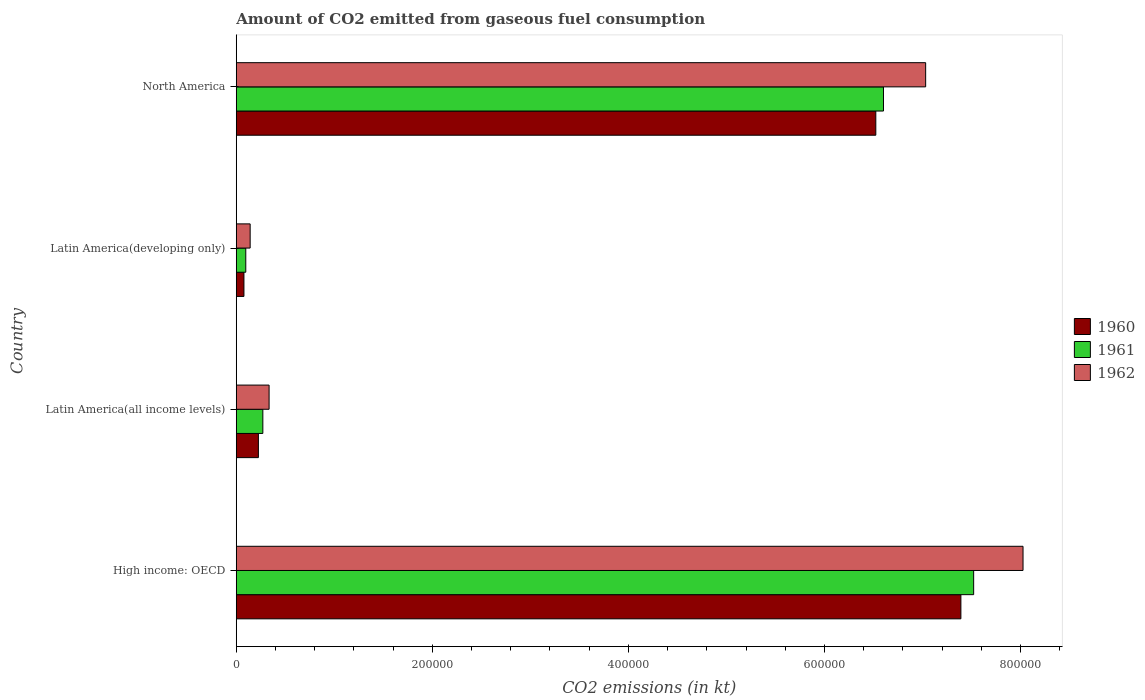How many different coloured bars are there?
Your answer should be compact. 3. How many groups of bars are there?
Your answer should be very brief. 4. Are the number of bars on each tick of the Y-axis equal?
Your answer should be compact. Yes. How many bars are there on the 4th tick from the bottom?
Make the answer very short. 3. What is the label of the 4th group of bars from the top?
Make the answer very short. High income: OECD. What is the amount of CO2 emitted in 1962 in North America?
Make the answer very short. 7.03e+05. Across all countries, what is the maximum amount of CO2 emitted in 1962?
Your answer should be compact. 8.03e+05. Across all countries, what is the minimum amount of CO2 emitted in 1962?
Give a very brief answer. 1.42e+04. In which country was the amount of CO2 emitted in 1962 maximum?
Provide a succinct answer. High income: OECD. In which country was the amount of CO2 emitted in 1962 minimum?
Give a very brief answer. Latin America(developing only). What is the total amount of CO2 emitted in 1962 in the graph?
Your response must be concise. 1.55e+06. What is the difference between the amount of CO2 emitted in 1961 in High income: OECD and that in Latin America(all income levels)?
Ensure brevity in your answer.  7.25e+05. What is the difference between the amount of CO2 emitted in 1960 in North America and the amount of CO2 emitted in 1961 in Latin America(all income levels)?
Your response must be concise. 6.25e+05. What is the average amount of CO2 emitted in 1962 per country?
Your response must be concise. 3.88e+05. What is the difference between the amount of CO2 emitted in 1961 and amount of CO2 emitted in 1962 in North America?
Your response must be concise. -4.30e+04. In how many countries, is the amount of CO2 emitted in 1962 greater than 80000 kt?
Provide a succinct answer. 2. What is the ratio of the amount of CO2 emitted in 1960 in High income: OECD to that in Latin America(developing only)?
Your answer should be compact. 94.3. What is the difference between the highest and the second highest amount of CO2 emitted in 1962?
Make the answer very short. 9.93e+04. What is the difference between the highest and the lowest amount of CO2 emitted in 1962?
Your answer should be very brief. 7.88e+05. In how many countries, is the amount of CO2 emitted in 1961 greater than the average amount of CO2 emitted in 1961 taken over all countries?
Your response must be concise. 2. Is the sum of the amount of CO2 emitted in 1962 in Latin America(all income levels) and North America greater than the maximum amount of CO2 emitted in 1961 across all countries?
Provide a succinct answer. No. What does the 3rd bar from the bottom in North America represents?
Your response must be concise. 1962. Is it the case that in every country, the sum of the amount of CO2 emitted in 1960 and amount of CO2 emitted in 1962 is greater than the amount of CO2 emitted in 1961?
Provide a succinct answer. Yes. What is the difference between two consecutive major ticks on the X-axis?
Make the answer very short. 2.00e+05. How many legend labels are there?
Your answer should be very brief. 3. How are the legend labels stacked?
Provide a succinct answer. Vertical. What is the title of the graph?
Your answer should be very brief. Amount of CO2 emitted from gaseous fuel consumption. What is the label or title of the X-axis?
Provide a short and direct response. CO2 emissions (in kt). What is the CO2 emissions (in kt) in 1960 in High income: OECD?
Make the answer very short. 7.39e+05. What is the CO2 emissions (in kt) of 1961 in High income: OECD?
Provide a short and direct response. 7.52e+05. What is the CO2 emissions (in kt) of 1962 in High income: OECD?
Provide a short and direct response. 8.03e+05. What is the CO2 emissions (in kt) in 1960 in Latin America(all income levels)?
Your answer should be compact. 2.26e+04. What is the CO2 emissions (in kt) of 1961 in Latin America(all income levels)?
Offer a terse response. 2.71e+04. What is the CO2 emissions (in kt) in 1962 in Latin America(all income levels)?
Ensure brevity in your answer.  3.35e+04. What is the CO2 emissions (in kt) in 1960 in Latin America(developing only)?
Make the answer very short. 7838.55. What is the CO2 emissions (in kt) of 1961 in Latin America(developing only)?
Make the answer very short. 9714.77. What is the CO2 emissions (in kt) in 1962 in Latin America(developing only)?
Provide a short and direct response. 1.42e+04. What is the CO2 emissions (in kt) of 1960 in North America?
Provide a short and direct response. 6.52e+05. What is the CO2 emissions (in kt) of 1961 in North America?
Your answer should be very brief. 6.60e+05. What is the CO2 emissions (in kt) of 1962 in North America?
Offer a very short reply. 7.03e+05. Across all countries, what is the maximum CO2 emissions (in kt) of 1960?
Keep it short and to the point. 7.39e+05. Across all countries, what is the maximum CO2 emissions (in kt) in 1961?
Give a very brief answer. 7.52e+05. Across all countries, what is the maximum CO2 emissions (in kt) of 1962?
Provide a short and direct response. 8.03e+05. Across all countries, what is the minimum CO2 emissions (in kt) in 1960?
Offer a terse response. 7838.55. Across all countries, what is the minimum CO2 emissions (in kt) of 1961?
Provide a short and direct response. 9714.77. Across all countries, what is the minimum CO2 emissions (in kt) in 1962?
Provide a short and direct response. 1.42e+04. What is the total CO2 emissions (in kt) in 1960 in the graph?
Your answer should be compact. 1.42e+06. What is the total CO2 emissions (in kt) in 1961 in the graph?
Provide a succinct answer. 1.45e+06. What is the total CO2 emissions (in kt) in 1962 in the graph?
Your answer should be compact. 1.55e+06. What is the difference between the CO2 emissions (in kt) of 1960 in High income: OECD and that in Latin America(all income levels)?
Make the answer very short. 7.17e+05. What is the difference between the CO2 emissions (in kt) of 1961 in High income: OECD and that in Latin America(all income levels)?
Your answer should be very brief. 7.25e+05. What is the difference between the CO2 emissions (in kt) in 1962 in High income: OECD and that in Latin America(all income levels)?
Make the answer very short. 7.69e+05. What is the difference between the CO2 emissions (in kt) in 1960 in High income: OECD and that in Latin America(developing only)?
Offer a terse response. 7.31e+05. What is the difference between the CO2 emissions (in kt) of 1961 in High income: OECD and that in Latin America(developing only)?
Keep it short and to the point. 7.42e+05. What is the difference between the CO2 emissions (in kt) in 1962 in High income: OECD and that in Latin America(developing only)?
Provide a short and direct response. 7.88e+05. What is the difference between the CO2 emissions (in kt) in 1960 in High income: OECD and that in North America?
Offer a terse response. 8.68e+04. What is the difference between the CO2 emissions (in kt) of 1961 in High income: OECD and that in North America?
Provide a short and direct response. 9.20e+04. What is the difference between the CO2 emissions (in kt) in 1962 in High income: OECD and that in North America?
Ensure brevity in your answer.  9.93e+04. What is the difference between the CO2 emissions (in kt) of 1960 in Latin America(all income levels) and that in Latin America(developing only)?
Your answer should be very brief. 1.47e+04. What is the difference between the CO2 emissions (in kt) in 1961 in Latin America(all income levels) and that in Latin America(developing only)?
Give a very brief answer. 1.74e+04. What is the difference between the CO2 emissions (in kt) in 1962 in Latin America(all income levels) and that in Latin America(developing only)?
Offer a terse response. 1.93e+04. What is the difference between the CO2 emissions (in kt) in 1960 in Latin America(all income levels) and that in North America?
Keep it short and to the point. -6.30e+05. What is the difference between the CO2 emissions (in kt) in 1961 in Latin America(all income levels) and that in North America?
Your response must be concise. -6.33e+05. What is the difference between the CO2 emissions (in kt) of 1962 in Latin America(all income levels) and that in North America?
Your answer should be very brief. -6.70e+05. What is the difference between the CO2 emissions (in kt) of 1960 in Latin America(developing only) and that in North America?
Ensure brevity in your answer.  -6.45e+05. What is the difference between the CO2 emissions (in kt) of 1961 in Latin America(developing only) and that in North America?
Give a very brief answer. -6.50e+05. What is the difference between the CO2 emissions (in kt) in 1962 in Latin America(developing only) and that in North America?
Keep it short and to the point. -6.89e+05. What is the difference between the CO2 emissions (in kt) of 1960 in High income: OECD and the CO2 emissions (in kt) of 1961 in Latin America(all income levels)?
Your response must be concise. 7.12e+05. What is the difference between the CO2 emissions (in kt) of 1960 in High income: OECD and the CO2 emissions (in kt) of 1962 in Latin America(all income levels)?
Your answer should be very brief. 7.06e+05. What is the difference between the CO2 emissions (in kt) of 1961 in High income: OECD and the CO2 emissions (in kt) of 1962 in Latin America(all income levels)?
Ensure brevity in your answer.  7.19e+05. What is the difference between the CO2 emissions (in kt) of 1960 in High income: OECD and the CO2 emissions (in kt) of 1961 in Latin America(developing only)?
Keep it short and to the point. 7.29e+05. What is the difference between the CO2 emissions (in kt) of 1960 in High income: OECD and the CO2 emissions (in kt) of 1962 in Latin America(developing only)?
Offer a terse response. 7.25e+05. What is the difference between the CO2 emissions (in kt) in 1961 in High income: OECD and the CO2 emissions (in kt) in 1962 in Latin America(developing only)?
Ensure brevity in your answer.  7.38e+05. What is the difference between the CO2 emissions (in kt) of 1960 in High income: OECD and the CO2 emissions (in kt) of 1961 in North America?
Keep it short and to the point. 7.90e+04. What is the difference between the CO2 emissions (in kt) in 1960 in High income: OECD and the CO2 emissions (in kt) in 1962 in North America?
Your answer should be compact. 3.59e+04. What is the difference between the CO2 emissions (in kt) of 1961 in High income: OECD and the CO2 emissions (in kt) of 1962 in North America?
Provide a short and direct response. 4.90e+04. What is the difference between the CO2 emissions (in kt) in 1960 in Latin America(all income levels) and the CO2 emissions (in kt) in 1961 in Latin America(developing only)?
Keep it short and to the point. 1.29e+04. What is the difference between the CO2 emissions (in kt) in 1960 in Latin America(all income levels) and the CO2 emissions (in kt) in 1962 in Latin America(developing only)?
Offer a terse response. 8397.37. What is the difference between the CO2 emissions (in kt) of 1961 in Latin America(all income levels) and the CO2 emissions (in kt) of 1962 in Latin America(developing only)?
Ensure brevity in your answer.  1.29e+04. What is the difference between the CO2 emissions (in kt) in 1960 in Latin America(all income levels) and the CO2 emissions (in kt) in 1961 in North America?
Make the answer very short. -6.38e+05. What is the difference between the CO2 emissions (in kt) of 1960 in Latin America(all income levels) and the CO2 emissions (in kt) of 1962 in North America?
Your answer should be very brief. -6.81e+05. What is the difference between the CO2 emissions (in kt) of 1961 in Latin America(all income levels) and the CO2 emissions (in kt) of 1962 in North America?
Offer a terse response. -6.76e+05. What is the difference between the CO2 emissions (in kt) of 1960 in Latin America(developing only) and the CO2 emissions (in kt) of 1961 in North America?
Provide a succinct answer. -6.52e+05. What is the difference between the CO2 emissions (in kt) of 1960 in Latin America(developing only) and the CO2 emissions (in kt) of 1962 in North America?
Your response must be concise. -6.95e+05. What is the difference between the CO2 emissions (in kt) of 1961 in Latin America(developing only) and the CO2 emissions (in kt) of 1962 in North America?
Offer a terse response. -6.93e+05. What is the average CO2 emissions (in kt) of 1960 per country?
Ensure brevity in your answer.  3.55e+05. What is the average CO2 emissions (in kt) of 1961 per country?
Your response must be concise. 3.62e+05. What is the average CO2 emissions (in kt) in 1962 per country?
Your answer should be very brief. 3.88e+05. What is the difference between the CO2 emissions (in kt) in 1960 and CO2 emissions (in kt) in 1961 in High income: OECD?
Your response must be concise. -1.30e+04. What is the difference between the CO2 emissions (in kt) in 1960 and CO2 emissions (in kt) in 1962 in High income: OECD?
Your answer should be compact. -6.34e+04. What is the difference between the CO2 emissions (in kt) of 1961 and CO2 emissions (in kt) of 1962 in High income: OECD?
Your answer should be very brief. -5.04e+04. What is the difference between the CO2 emissions (in kt) of 1960 and CO2 emissions (in kt) of 1961 in Latin America(all income levels)?
Provide a succinct answer. -4542.92. What is the difference between the CO2 emissions (in kt) in 1960 and CO2 emissions (in kt) in 1962 in Latin America(all income levels)?
Offer a very short reply. -1.09e+04. What is the difference between the CO2 emissions (in kt) in 1961 and CO2 emissions (in kt) in 1962 in Latin America(all income levels)?
Ensure brevity in your answer.  -6377.63. What is the difference between the CO2 emissions (in kt) in 1960 and CO2 emissions (in kt) in 1961 in Latin America(developing only)?
Keep it short and to the point. -1876.23. What is the difference between the CO2 emissions (in kt) in 1960 and CO2 emissions (in kt) in 1962 in Latin America(developing only)?
Provide a succinct answer. -6343.06. What is the difference between the CO2 emissions (in kt) of 1961 and CO2 emissions (in kt) of 1962 in Latin America(developing only)?
Your answer should be compact. -4466.83. What is the difference between the CO2 emissions (in kt) of 1960 and CO2 emissions (in kt) of 1961 in North America?
Ensure brevity in your answer.  -7828.66. What is the difference between the CO2 emissions (in kt) in 1960 and CO2 emissions (in kt) in 1962 in North America?
Your answer should be compact. -5.08e+04. What is the difference between the CO2 emissions (in kt) of 1961 and CO2 emissions (in kt) of 1962 in North America?
Give a very brief answer. -4.30e+04. What is the ratio of the CO2 emissions (in kt) in 1960 in High income: OECD to that in Latin America(all income levels)?
Your response must be concise. 32.74. What is the ratio of the CO2 emissions (in kt) of 1961 in High income: OECD to that in Latin America(all income levels)?
Ensure brevity in your answer.  27.73. What is the ratio of the CO2 emissions (in kt) in 1962 in High income: OECD to that in Latin America(all income levels)?
Provide a short and direct response. 23.96. What is the ratio of the CO2 emissions (in kt) in 1960 in High income: OECD to that in Latin America(developing only)?
Ensure brevity in your answer.  94.3. What is the ratio of the CO2 emissions (in kt) of 1961 in High income: OECD to that in Latin America(developing only)?
Provide a succinct answer. 77.43. What is the ratio of the CO2 emissions (in kt) in 1962 in High income: OECD to that in Latin America(developing only)?
Offer a terse response. 56.59. What is the ratio of the CO2 emissions (in kt) in 1960 in High income: OECD to that in North America?
Make the answer very short. 1.13. What is the ratio of the CO2 emissions (in kt) of 1961 in High income: OECD to that in North America?
Keep it short and to the point. 1.14. What is the ratio of the CO2 emissions (in kt) of 1962 in High income: OECD to that in North America?
Ensure brevity in your answer.  1.14. What is the ratio of the CO2 emissions (in kt) of 1960 in Latin America(all income levels) to that in Latin America(developing only)?
Ensure brevity in your answer.  2.88. What is the ratio of the CO2 emissions (in kt) in 1961 in Latin America(all income levels) to that in Latin America(developing only)?
Provide a succinct answer. 2.79. What is the ratio of the CO2 emissions (in kt) of 1962 in Latin America(all income levels) to that in Latin America(developing only)?
Make the answer very short. 2.36. What is the ratio of the CO2 emissions (in kt) of 1960 in Latin America(all income levels) to that in North America?
Provide a short and direct response. 0.03. What is the ratio of the CO2 emissions (in kt) of 1961 in Latin America(all income levels) to that in North America?
Make the answer very short. 0.04. What is the ratio of the CO2 emissions (in kt) in 1962 in Latin America(all income levels) to that in North America?
Ensure brevity in your answer.  0.05. What is the ratio of the CO2 emissions (in kt) in 1960 in Latin America(developing only) to that in North America?
Provide a succinct answer. 0.01. What is the ratio of the CO2 emissions (in kt) of 1961 in Latin America(developing only) to that in North America?
Provide a succinct answer. 0.01. What is the ratio of the CO2 emissions (in kt) in 1962 in Latin America(developing only) to that in North America?
Provide a short and direct response. 0.02. What is the difference between the highest and the second highest CO2 emissions (in kt) of 1960?
Make the answer very short. 8.68e+04. What is the difference between the highest and the second highest CO2 emissions (in kt) in 1961?
Give a very brief answer. 9.20e+04. What is the difference between the highest and the second highest CO2 emissions (in kt) of 1962?
Give a very brief answer. 9.93e+04. What is the difference between the highest and the lowest CO2 emissions (in kt) of 1960?
Provide a succinct answer. 7.31e+05. What is the difference between the highest and the lowest CO2 emissions (in kt) of 1961?
Give a very brief answer. 7.42e+05. What is the difference between the highest and the lowest CO2 emissions (in kt) of 1962?
Your response must be concise. 7.88e+05. 